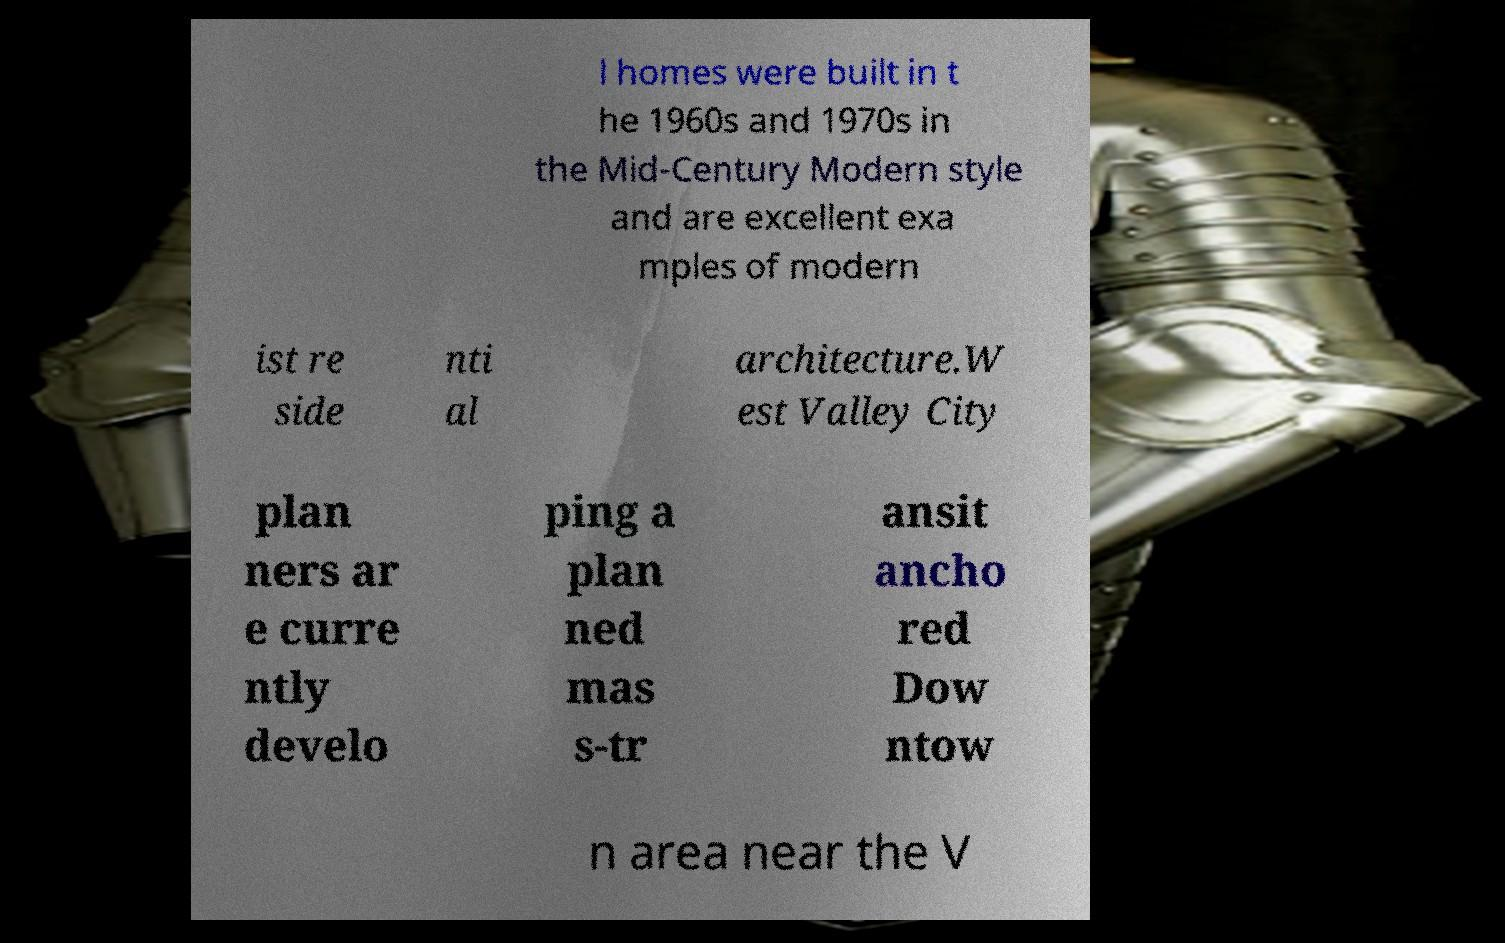For documentation purposes, I need the text within this image transcribed. Could you provide that? l homes were built in t he 1960s and 1970s in the Mid-Century Modern style and are excellent exa mples of modern ist re side nti al architecture.W est Valley City plan ners ar e curre ntly develo ping a plan ned mas s-tr ansit ancho red Dow ntow n area near the V 